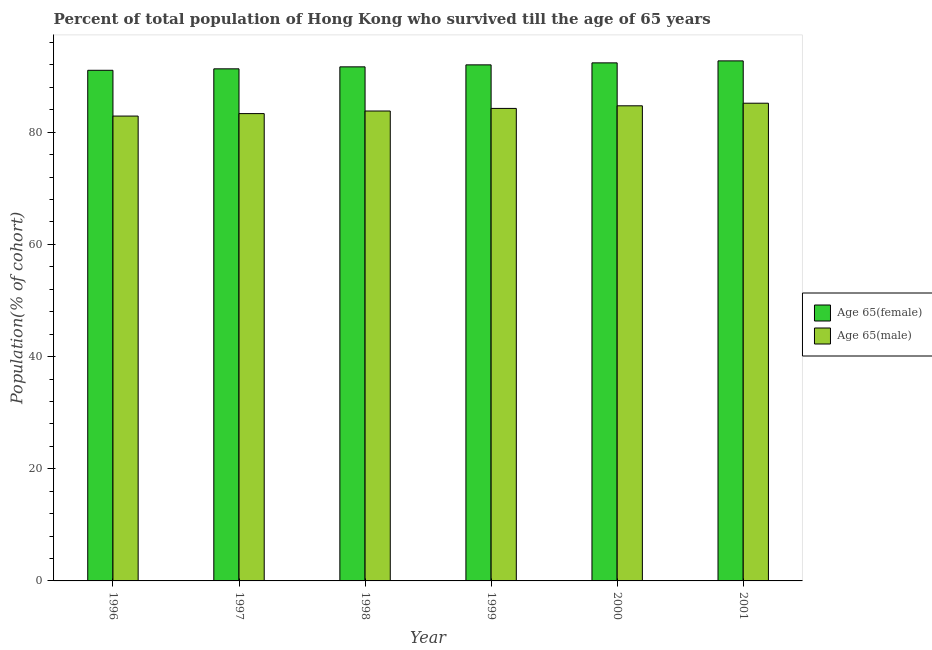How many different coloured bars are there?
Your response must be concise. 2. How many groups of bars are there?
Your answer should be very brief. 6. Are the number of bars per tick equal to the number of legend labels?
Your answer should be compact. Yes. How many bars are there on the 3rd tick from the left?
Your response must be concise. 2. How many bars are there on the 4th tick from the right?
Your answer should be very brief. 2. What is the label of the 1st group of bars from the left?
Keep it short and to the point. 1996. In how many cases, is the number of bars for a given year not equal to the number of legend labels?
Offer a very short reply. 0. What is the percentage of male population who survived till age of 65 in 2001?
Provide a short and direct response. 85.17. Across all years, what is the maximum percentage of male population who survived till age of 65?
Your response must be concise. 85.17. Across all years, what is the minimum percentage of male population who survived till age of 65?
Your answer should be very brief. 82.88. In which year was the percentage of male population who survived till age of 65 minimum?
Keep it short and to the point. 1996. What is the total percentage of male population who survived till age of 65 in the graph?
Your response must be concise. 504.12. What is the difference between the percentage of male population who survived till age of 65 in 1998 and that in 2001?
Your response must be concise. -1.39. What is the difference between the percentage of male population who survived till age of 65 in 2000 and the percentage of female population who survived till age of 65 in 1997?
Offer a terse response. 1.39. What is the average percentage of female population who survived till age of 65 per year?
Provide a succinct answer. 91.85. What is the ratio of the percentage of female population who survived till age of 65 in 1997 to that in 1999?
Offer a very short reply. 0.99. Is the difference between the percentage of male population who survived till age of 65 in 1998 and 1999 greater than the difference between the percentage of female population who survived till age of 65 in 1998 and 1999?
Provide a succinct answer. No. What is the difference between the highest and the second highest percentage of female population who survived till age of 65?
Provide a succinct answer. 0.36. What is the difference between the highest and the lowest percentage of female population who survived till age of 65?
Offer a very short reply. 1.68. In how many years, is the percentage of male population who survived till age of 65 greater than the average percentage of male population who survived till age of 65 taken over all years?
Give a very brief answer. 3. Is the sum of the percentage of female population who survived till age of 65 in 1998 and 2001 greater than the maximum percentage of male population who survived till age of 65 across all years?
Keep it short and to the point. Yes. What does the 2nd bar from the left in 1997 represents?
Your answer should be compact. Age 65(male). What does the 1st bar from the right in 1998 represents?
Keep it short and to the point. Age 65(male). How many bars are there?
Make the answer very short. 12. How are the legend labels stacked?
Keep it short and to the point. Vertical. What is the title of the graph?
Your answer should be compact. Percent of total population of Hong Kong who survived till the age of 65 years. Does "Adolescent fertility rate" appear as one of the legend labels in the graph?
Offer a terse response. No. What is the label or title of the X-axis?
Provide a succinct answer. Year. What is the label or title of the Y-axis?
Your answer should be compact. Population(% of cohort). What is the Population(% of cohort) of Age 65(female) in 1996?
Provide a short and direct response. 91.05. What is the Population(% of cohort) of Age 65(male) in 1996?
Your response must be concise. 82.88. What is the Population(% of cohort) in Age 65(female) in 1997?
Give a very brief answer. 91.3. What is the Population(% of cohort) in Age 65(male) in 1997?
Give a very brief answer. 83.32. What is the Population(% of cohort) in Age 65(female) in 1998?
Give a very brief answer. 91.66. What is the Population(% of cohort) of Age 65(male) in 1998?
Your response must be concise. 83.79. What is the Population(% of cohort) in Age 65(female) in 1999?
Keep it short and to the point. 92.01. What is the Population(% of cohort) of Age 65(male) in 1999?
Provide a succinct answer. 84.25. What is the Population(% of cohort) of Age 65(female) in 2000?
Your response must be concise. 92.37. What is the Population(% of cohort) in Age 65(male) in 2000?
Offer a very short reply. 84.71. What is the Population(% of cohort) in Age 65(female) in 2001?
Provide a short and direct response. 92.72. What is the Population(% of cohort) in Age 65(male) in 2001?
Ensure brevity in your answer.  85.17. Across all years, what is the maximum Population(% of cohort) in Age 65(female)?
Your answer should be compact. 92.72. Across all years, what is the maximum Population(% of cohort) in Age 65(male)?
Offer a terse response. 85.17. Across all years, what is the minimum Population(% of cohort) of Age 65(female)?
Make the answer very short. 91.05. Across all years, what is the minimum Population(% of cohort) of Age 65(male)?
Your answer should be compact. 82.88. What is the total Population(% of cohort) of Age 65(female) in the graph?
Offer a very short reply. 551.11. What is the total Population(% of cohort) in Age 65(male) in the graph?
Provide a succinct answer. 504.12. What is the difference between the Population(% of cohort) in Age 65(female) in 1996 and that in 1997?
Give a very brief answer. -0.26. What is the difference between the Population(% of cohort) of Age 65(male) in 1996 and that in 1997?
Keep it short and to the point. -0.44. What is the difference between the Population(% of cohort) in Age 65(female) in 1996 and that in 1998?
Your answer should be very brief. -0.61. What is the difference between the Population(% of cohort) in Age 65(male) in 1996 and that in 1998?
Ensure brevity in your answer.  -0.9. What is the difference between the Population(% of cohort) in Age 65(female) in 1996 and that in 1999?
Ensure brevity in your answer.  -0.97. What is the difference between the Population(% of cohort) in Age 65(male) in 1996 and that in 1999?
Provide a short and direct response. -1.37. What is the difference between the Population(% of cohort) of Age 65(female) in 1996 and that in 2000?
Your response must be concise. -1.32. What is the difference between the Population(% of cohort) of Age 65(male) in 1996 and that in 2000?
Your answer should be very brief. -1.83. What is the difference between the Population(% of cohort) of Age 65(female) in 1996 and that in 2001?
Your response must be concise. -1.68. What is the difference between the Population(% of cohort) of Age 65(male) in 1996 and that in 2001?
Ensure brevity in your answer.  -2.29. What is the difference between the Population(% of cohort) in Age 65(female) in 1997 and that in 1998?
Your response must be concise. -0.35. What is the difference between the Population(% of cohort) in Age 65(male) in 1997 and that in 1998?
Your answer should be compact. -0.46. What is the difference between the Population(% of cohort) in Age 65(female) in 1997 and that in 1999?
Your response must be concise. -0.71. What is the difference between the Population(% of cohort) in Age 65(male) in 1997 and that in 1999?
Give a very brief answer. -0.93. What is the difference between the Population(% of cohort) in Age 65(female) in 1997 and that in 2000?
Make the answer very short. -1.07. What is the difference between the Population(% of cohort) of Age 65(male) in 1997 and that in 2000?
Your answer should be compact. -1.39. What is the difference between the Population(% of cohort) of Age 65(female) in 1997 and that in 2001?
Provide a succinct answer. -1.42. What is the difference between the Population(% of cohort) in Age 65(male) in 1997 and that in 2001?
Offer a terse response. -1.85. What is the difference between the Population(% of cohort) in Age 65(female) in 1998 and that in 1999?
Your response must be concise. -0.35. What is the difference between the Population(% of cohort) of Age 65(male) in 1998 and that in 1999?
Provide a short and direct response. -0.46. What is the difference between the Population(% of cohort) of Age 65(female) in 1998 and that in 2000?
Your answer should be very brief. -0.71. What is the difference between the Population(% of cohort) of Age 65(male) in 1998 and that in 2000?
Provide a succinct answer. -0.93. What is the difference between the Population(% of cohort) of Age 65(female) in 1998 and that in 2001?
Give a very brief answer. -1.07. What is the difference between the Population(% of cohort) in Age 65(male) in 1998 and that in 2001?
Provide a short and direct response. -1.39. What is the difference between the Population(% of cohort) of Age 65(female) in 1999 and that in 2000?
Offer a very short reply. -0.35. What is the difference between the Population(% of cohort) of Age 65(male) in 1999 and that in 2000?
Provide a short and direct response. -0.46. What is the difference between the Population(% of cohort) of Age 65(female) in 1999 and that in 2001?
Provide a succinct answer. -0.71. What is the difference between the Population(% of cohort) of Age 65(male) in 1999 and that in 2001?
Ensure brevity in your answer.  -0.93. What is the difference between the Population(% of cohort) of Age 65(female) in 2000 and that in 2001?
Provide a succinct answer. -0.35. What is the difference between the Population(% of cohort) in Age 65(male) in 2000 and that in 2001?
Ensure brevity in your answer.  -0.46. What is the difference between the Population(% of cohort) of Age 65(female) in 1996 and the Population(% of cohort) of Age 65(male) in 1997?
Your answer should be very brief. 7.72. What is the difference between the Population(% of cohort) in Age 65(female) in 1996 and the Population(% of cohort) in Age 65(male) in 1998?
Your response must be concise. 7.26. What is the difference between the Population(% of cohort) of Age 65(female) in 1996 and the Population(% of cohort) of Age 65(male) in 1999?
Ensure brevity in your answer.  6.8. What is the difference between the Population(% of cohort) in Age 65(female) in 1996 and the Population(% of cohort) in Age 65(male) in 2000?
Provide a succinct answer. 6.33. What is the difference between the Population(% of cohort) of Age 65(female) in 1996 and the Population(% of cohort) of Age 65(male) in 2001?
Keep it short and to the point. 5.87. What is the difference between the Population(% of cohort) in Age 65(female) in 1997 and the Population(% of cohort) in Age 65(male) in 1998?
Make the answer very short. 7.52. What is the difference between the Population(% of cohort) in Age 65(female) in 1997 and the Population(% of cohort) in Age 65(male) in 1999?
Offer a terse response. 7.05. What is the difference between the Population(% of cohort) of Age 65(female) in 1997 and the Population(% of cohort) of Age 65(male) in 2000?
Your response must be concise. 6.59. What is the difference between the Population(% of cohort) of Age 65(female) in 1997 and the Population(% of cohort) of Age 65(male) in 2001?
Your answer should be very brief. 6.13. What is the difference between the Population(% of cohort) of Age 65(female) in 1998 and the Population(% of cohort) of Age 65(male) in 1999?
Keep it short and to the point. 7.41. What is the difference between the Population(% of cohort) of Age 65(female) in 1998 and the Population(% of cohort) of Age 65(male) in 2000?
Give a very brief answer. 6.95. What is the difference between the Population(% of cohort) of Age 65(female) in 1998 and the Population(% of cohort) of Age 65(male) in 2001?
Keep it short and to the point. 6.48. What is the difference between the Population(% of cohort) of Age 65(female) in 1999 and the Population(% of cohort) of Age 65(male) in 2000?
Offer a very short reply. 7.3. What is the difference between the Population(% of cohort) of Age 65(female) in 1999 and the Population(% of cohort) of Age 65(male) in 2001?
Your answer should be very brief. 6.84. What is the difference between the Population(% of cohort) of Age 65(female) in 2000 and the Population(% of cohort) of Age 65(male) in 2001?
Ensure brevity in your answer.  7.19. What is the average Population(% of cohort) of Age 65(female) per year?
Your answer should be compact. 91.85. What is the average Population(% of cohort) in Age 65(male) per year?
Offer a very short reply. 84.02. In the year 1996, what is the difference between the Population(% of cohort) in Age 65(female) and Population(% of cohort) in Age 65(male)?
Give a very brief answer. 8.16. In the year 1997, what is the difference between the Population(% of cohort) of Age 65(female) and Population(% of cohort) of Age 65(male)?
Provide a short and direct response. 7.98. In the year 1998, what is the difference between the Population(% of cohort) of Age 65(female) and Population(% of cohort) of Age 65(male)?
Ensure brevity in your answer.  7.87. In the year 1999, what is the difference between the Population(% of cohort) of Age 65(female) and Population(% of cohort) of Age 65(male)?
Provide a short and direct response. 7.76. In the year 2000, what is the difference between the Population(% of cohort) of Age 65(female) and Population(% of cohort) of Age 65(male)?
Ensure brevity in your answer.  7.66. In the year 2001, what is the difference between the Population(% of cohort) of Age 65(female) and Population(% of cohort) of Age 65(male)?
Your answer should be very brief. 7.55. What is the ratio of the Population(% of cohort) of Age 65(female) in 1996 to that in 1998?
Provide a succinct answer. 0.99. What is the ratio of the Population(% of cohort) in Age 65(male) in 1996 to that in 1998?
Offer a very short reply. 0.99. What is the ratio of the Population(% of cohort) of Age 65(female) in 1996 to that in 1999?
Your response must be concise. 0.99. What is the ratio of the Population(% of cohort) of Age 65(male) in 1996 to that in 1999?
Your response must be concise. 0.98. What is the ratio of the Population(% of cohort) in Age 65(female) in 1996 to that in 2000?
Your answer should be compact. 0.99. What is the ratio of the Population(% of cohort) of Age 65(male) in 1996 to that in 2000?
Offer a terse response. 0.98. What is the ratio of the Population(% of cohort) in Age 65(female) in 1996 to that in 2001?
Keep it short and to the point. 0.98. What is the ratio of the Population(% of cohort) in Age 65(male) in 1996 to that in 2001?
Your answer should be very brief. 0.97. What is the ratio of the Population(% of cohort) in Age 65(female) in 1997 to that in 1998?
Provide a short and direct response. 1. What is the ratio of the Population(% of cohort) in Age 65(male) in 1997 to that in 1998?
Provide a succinct answer. 0.99. What is the ratio of the Population(% of cohort) in Age 65(male) in 1997 to that in 2000?
Offer a very short reply. 0.98. What is the ratio of the Population(% of cohort) of Age 65(female) in 1997 to that in 2001?
Your answer should be very brief. 0.98. What is the ratio of the Population(% of cohort) in Age 65(male) in 1997 to that in 2001?
Offer a very short reply. 0.98. What is the ratio of the Population(% of cohort) of Age 65(female) in 1998 to that in 1999?
Offer a terse response. 1. What is the ratio of the Population(% of cohort) of Age 65(male) in 1998 to that in 1999?
Provide a succinct answer. 0.99. What is the ratio of the Population(% of cohort) of Age 65(female) in 1998 to that in 2000?
Your response must be concise. 0.99. What is the ratio of the Population(% of cohort) of Age 65(male) in 1998 to that in 2001?
Make the answer very short. 0.98. What is the ratio of the Population(% of cohort) of Age 65(female) in 1999 to that in 2001?
Keep it short and to the point. 0.99. What is the difference between the highest and the second highest Population(% of cohort) in Age 65(female)?
Your answer should be compact. 0.35. What is the difference between the highest and the second highest Population(% of cohort) of Age 65(male)?
Give a very brief answer. 0.46. What is the difference between the highest and the lowest Population(% of cohort) in Age 65(female)?
Offer a very short reply. 1.68. What is the difference between the highest and the lowest Population(% of cohort) in Age 65(male)?
Make the answer very short. 2.29. 